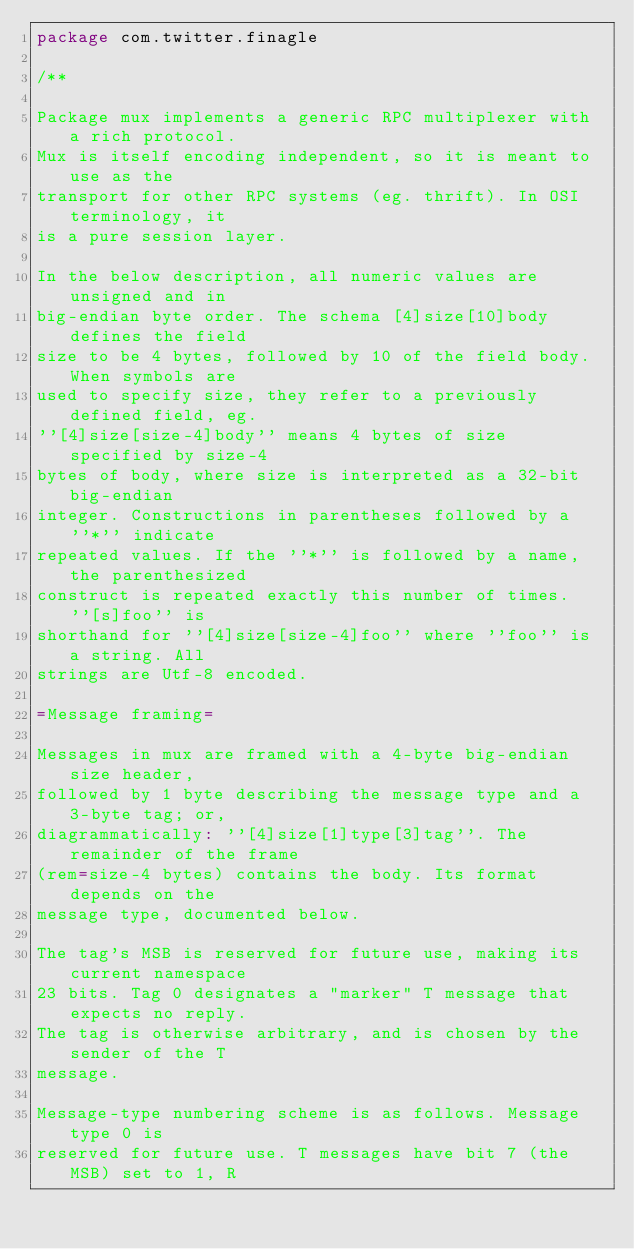<code> <loc_0><loc_0><loc_500><loc_500><_Scala_>package com.twitter.finagle

/**

Package mux implements a generic RPC multiplexer with a rich protocol.
Mux is itself encoding independent, so it is meant to use as the
transport for other RPC systems (eg. thrift). In OSI terminology, it
is a pure session layer.

In the below description, all numeric values are unsigned and in
big-endian byte order. The schema [4]size[10]body defines the field
size to be 4 bytes, followed by 10 of the field body. When symbols are
used to specify size, they refer to a previously defined field, eg.
''[4]size[size-4]body'' means 4 bytes of size specified by size-4
bytes of body, where size is interpreted as a 32-bit big-endian
integer. Constructions in parentheses followed by a ''*'' indicate
repeated values. If the ''*'' is followed by a name, the parenthesized
construct is repeated exactly this number of times. ''[s]foo'' is
shorthand for ''[4]size[size-4]foo'' where ''foo'' is a string. All
strings are Utf-8 encoded.

=Message framing=

Messages in mux are framed with a 4-byte big-endian size header,
followed by 1 byte describing the message type and a 3-byte tag; or,
diagrammatically: ''[4]size[1]type[3]tag''. The remainder of the frame
(rem=size-4 bytes) contains the body. Its format depends on the
message type, documented below.

The tag's MSB is reserved for future use, making its current namespace
23 bits. Tag 0 designates a "marker" T message that expects no reply.
The tag is otherwise arbitrary, and is chosen by the sender of the T
message.

Message-type numbering scheme is as follows. Message type 0 is
reserved for future use. T messages have bit 7 (the MSB) set to 1, R</code> 